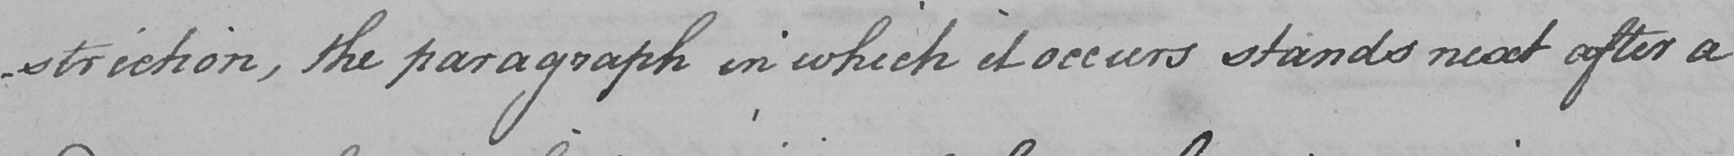Transcribe the text shown in this historical manuscript line. -triction , the paragraph in which it occurs stands next after a 